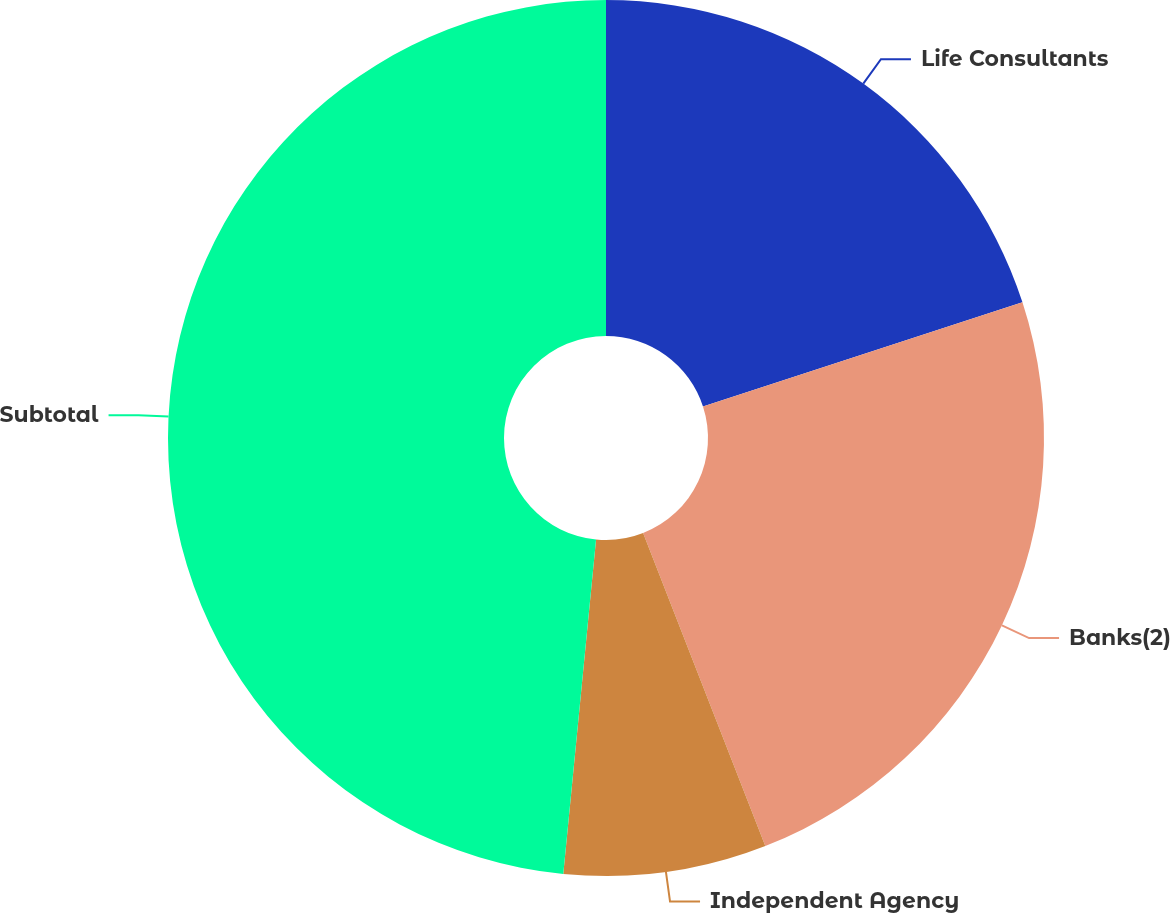Convert chart to OTSL. <chart><loc_0><loc_0><loc_500><loc_500><pie_chart><fcel>Life Consultants<fcel>Banks(2)<fcel>Independent Agency<fcel>Subtotal<nl><fcel>19.99%<fcel>24.09%<fcel>7.48%<fcel>48.45%<nl></chart> 